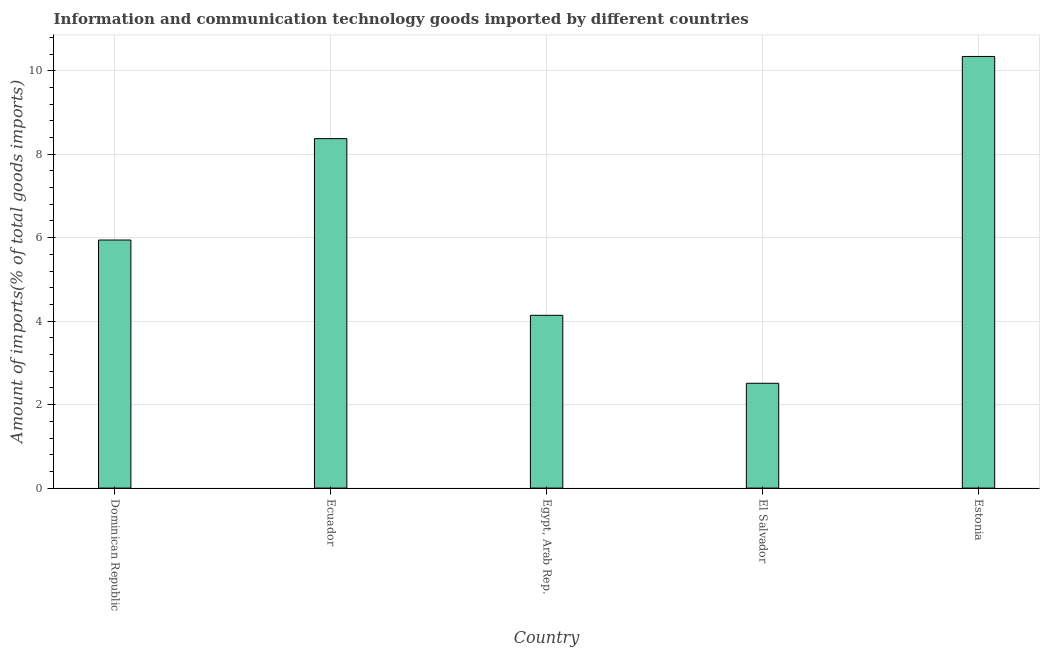Does the graph contain grids?
Make the answer very short. Yes. What is the title of the graph?
Provide a succinct answer. Information and communication technology goods imported by different countries. What is the label or title of the Y-axis?
Offer a terse response. Amount of imports(% of total goods imports). What is the amount of ict goods imports in Dominican Republic?
Your response must be concise. 5.94. Across all countries, what is the maximum amount of ict goods imports?
Your answer should be compact. 10.34. Across all countries, what is the minimum amount of ict goods imports?
Provide a succinct answer. 2.51. In which country was the amount of ict goods imports maximum?
Your response must be concise. Estonia. In which country was the amount of ict goods imports minimum?
Offer a terse response. El Salvador. What is the sum of the amount of ict goods imports?
Give a very brief answer. 31.31. What is the difference between the amount of ict goods imports in Dominican Republic and El Salvador?
Your response must be concise. 3.43. What is the average amount of ict goods imports per country?
Keep it short and to the point. 6.26. What is the median amount of ict goods imports?
Offer a very short reply. 5.94. In how many countries, is the amount of ict goods imports greater than 4.8 %?
Make the answer very short. 3. What is the ratio of the amount of ict goods imports in Ecuador to that in Estonia?
Keep it short and to the point. 0.81. Is the amount of ict goods imports in Dominican Republic less than that in Ecuador?
Ensure brevity in your answer.  Yes. What is the difference between the highest and the second highest amount of ict goods imports?
Your answer should be very brief. 1.97. Is the sum of the amount of ict goods imports in Egypt, Arab Rep. and El Salvador greater than the maximum amount of ict goods imports across all countries?
Ensure brevity in your answer.  No. What is the difference between the highest and the lowest amount of ict goods imports?
Your answer should be very brief. 7.83. How many bars are there?
Give a very brief answer. 5. How many countries are there in the graph?
Offer a terse response. 5. Are the values on the major ticks of Y-axis written in scientific E-notation?
Make the answer very short. No. What is the Amount of imports(% of total goods imports) of Dominican Republic?
Your answer should be very brief. 5.94. What is the Amount of imports(% of total goods imports) of Ecuador?
Keep it short and to the point. 8.37. What is the Amount of imports(% of total goods imports) of Egypt, Arab Rep.?
Provide a succinct answer. 4.14. What is the Amount of imports(% of total goods imports) in El Salvador?
Ensure brevity in your answer.  2.51. What is the Amount of imports(% of total goods imports) in Estonia?
Your response must be concise. 10.34. What is the difference between the Amount of imports(% of total goods imports) in Dominican Republic and Ecuador?
Your response must be concise. -2.43. What is the difference between the Amount of imports(% of total goods imports) in Dominican Republic and Egypt, Arab Rep.?
Keep it short and to the point. 1.8. What is the difference between the Amount of imports(% of total goods imports) in Dominican Republic and El Salvador?
Your answer should be compact. 3.43. What is the difference between the Amount of imports(% of total goods imports) in Dominican Republic and Estonia?
Provide a short and direct response. -4.4. What is the difference between the Amount of imports(% of total goods imports) in Ecuador and Egypt, Arab Rep.?
Provide a succinct answer. 4.23. What is the difference between the Amount of imports(% of total goods imports) in Ecuador and El Salvador?
Keep it short and to the point. 5.86. What is the difference between the Amount of imports(% of total goods imports) in Ecuador and Estonia?
Your answer should be very brief. -1.97. What is the difference between the Amount of imports(% of total goods imports) in Egypt, Arab Rep. and El Salvador?
Give a very brief answer. 1.63. What is the difference between the Amount of imports(% of total goods imports) in Egypt, Arab Rep. and Estonia?
Keep it short and to the point. -6.2. What is the difference between the Amount of imports(% of total goods imports) in El Salvador and Estonia?
Keep it short and to the point. -7.83. What is the ratio of the Amount of imports(% of total goods imports) in Dominican Republic to that in Ecuador?
Your answer should be very brief. 0.71. What is the ratio of the Amount of imports(% of total goods imports) in Dominican Republic to that in Egypt, Arab Rep.?
Offer a very short reply. 1.44. What is the ratio of the Amount of imports(% of total goods imports) in Dominican Republic to that in El Salvador?
Offer a terse response. 2.37. What is the ratio of the Amount of imports(% of total goods imports) in Dominican Republic to that in Estonia?
Your response must be concise. 0.57. What is the ratio of the Amount of imports(% of total goods imports) in Ecuador to that in Egypt, Arab Rep.?
Give a very brief answer. 2.02. What is the ratio of the Amount of imports(% of total goods imports) in Ecuador to that in El Salvador?
Provide a short and direct response. 3.33. What is the ratio of the Amount of imports(% of total goods imports) in Ecuador to that in Estonia?
Offer a very short reply. 0.81. What is the ratio of the Amount of imports(% of total goods imports) in Egypt, Arab Rep. to that in El Salvador?
Give a very brief answer. 1.65. What is the ratio of the Amount of imports(% of total goods imports) in El Salvador to that in Estonia?
Provide a succinct answer. 0.24. 